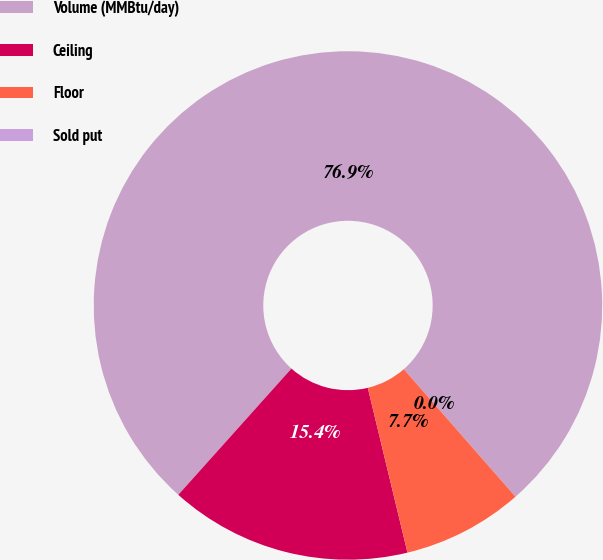Convert chart. <chart><loc_0><loc_0><loc_500><loc_500><pie_chart><fcel>Volume (MMBtu/day)<fcel>Ceiling<fcel>Floor<fcel>Sold put<nl><fcel>76.92%<fcel>15.39%<fcel>7.69%<fcel>0.0%<nl></chart> 